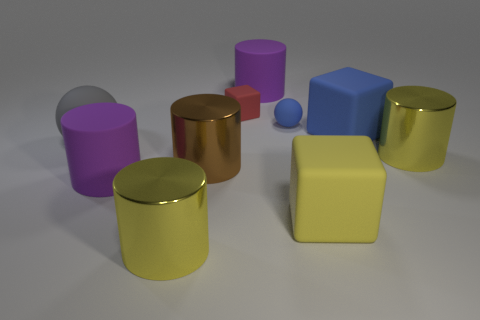There is a cube that is the same size as the blue sphere; what material is it?
Your answer should be compact. Rubber. Is the number of big purple matte cylinders that are behind the tiny cube less than the number of cyan matte cylinders?
Offer a very short reply. No. What is the shape of the big purple matte object that is in front of the big matte block behind the matte ball that is left of the tiny blue ball?
Keep it short and to the point. Cylinder. What is the size of the purple matte thing that is in front of the gray matte ball?
Your response must be concise. Large. There is a blue thing that is the same size as the yellow matte cube; what shape is it?
Ensure brevity in your answer.  Cube. What number of objects are either small red rubber cubes or big matte cylinders that are in front of the gray ball?
Offer a terse response. 2. What number of large yellow metallic cylinders are in front of the purple object on the left side of the yellow thing that is in front of the big yellow rubber block?
Provide a short and direct response. 1. What is the color of the other sphere that is made of the same material as the gray ball?
Ensure brevity in your answer.  Blue. There is a yellow cylinder that is on the left side of the red matte cube; does it have the same size as the brown metallic cylinder?
Your response must be concise. Yes. What number of objects are either red rubber cubes or large matte blocks?
Make the answer very short. 3. 